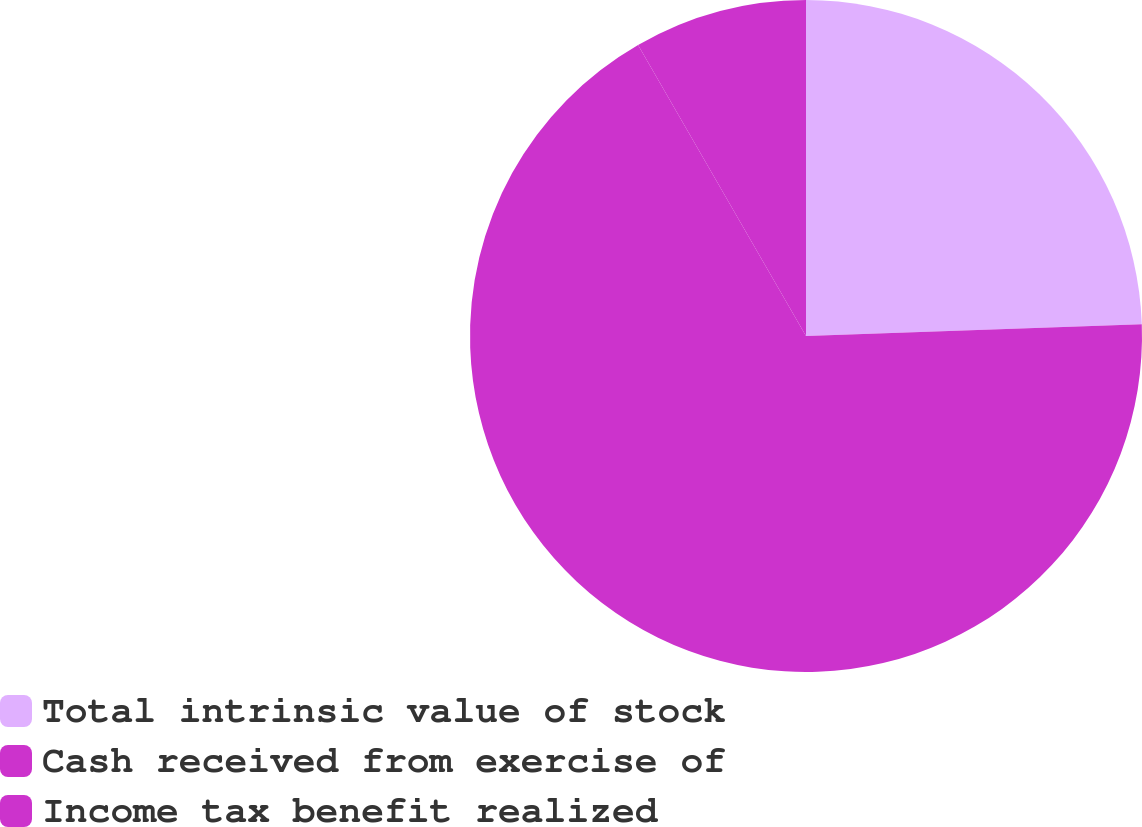Convert chart. <chart><loc_0><loc_0><loc_500><loc_500><pie_chart><fcel>Total intrinsic value of stock<fcel>Cash received from exercise of<fcel>Income tax benefit realized<nl><fcel>24.44%<fcel>67.22%<fcel>8.33%<nl></chart> 